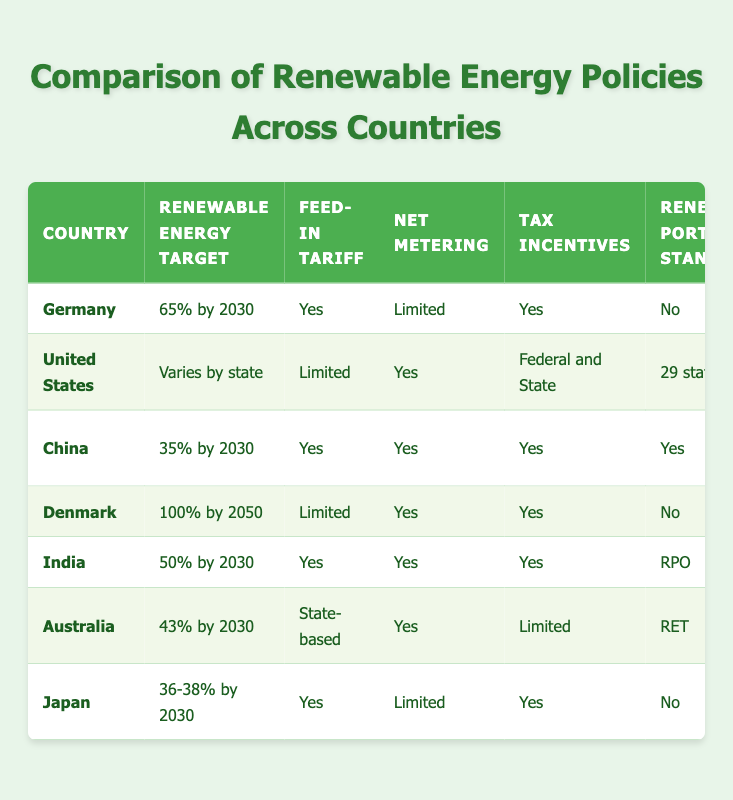What is the renewable energy target for Germany? The table specifies that Germany's renewable energy target is "65% by 2030." This value can be found directly under the "Renewable Energy Target" column for Germany.
Answer: 65% by 2030 Which countries have a feed-in tariff? By examining the "Feed-in Tariff" column, we can see that Germany, China, India, Australia, and Japan have a feed-in tariff. The values "Yes" indicate the presence of this policy in these countries.
Answer: Germany, China, India, Australia, Japan Does Denmark have a Renewable Portfolio Standard? The table indicates "No" under the "Renewable Portfolio Standard" for Denmark, which means they do not have this particular policy. This is a fact-based question with a straightforward answer based on that specific entry.
Answer: No Which country has the highest renewable energy target? The highest renewable energy target listed in the table is Denmark's "100% by 2050." No other country listed has a target that exceeds this value, revealing Denmark’s ambitious goal.
Answer: 100% by 2050 How many countries have both net metering and tax incentives? Looking across the table for both "Net Metering" and "Tax Incentives," countries that meet both criteria are China, India, and Australia. This requires checking both columns for "Yes" entries simultaneously. Hence, there are three countries: China, India, and Australia.
Answer: 3 Is the carbon pricing system in the United States regional or national? The table specifies that the carbon pricing in the United States is "Regional (RGGI)." There is no indication of a national system, and the entry clearly states the regional nature of the pricing.
Answer: Regional What is the average renewable energy target of the countries listed in the table? To find the average renewable energy target, we first extract the numeric parts of the targets: Germany (65), China (35), India (50), Australia (43), Japan (37) (taking the average of 36-38), and exclude US and Denmark as their targets vary or are further into the future. The sum of these is 65 + 35 + 50 + 43 + 37 = 230. Dividing by the 5 countries gives an average of 230/5 = 46.
Answer: 46 Which country has no green certificates? By checking the "Green Certificates" column, we see that Denmark has "No" listed. This indicates that Denmark does not have a system for green certificates, while all other countries have "Yes."
Answer: Denmark 